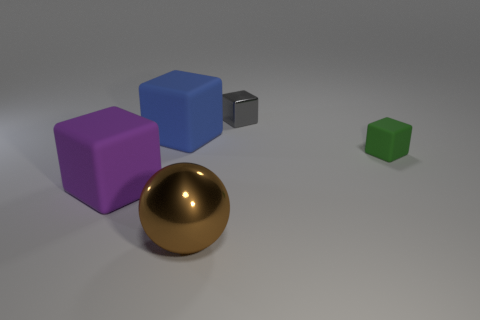The small object that is behind the rubber object that is right of the large matte object that is behind the big purple block is made of what material?
Offer a terse response. Metal. There is a big object behind the purple matte object; what is its shape?
Give a very brief answer. Cube. The thing that is the same material as the large brown sphere is what size?
Provide a succinct answer. Small. What number of blue objects are the same shape as the green matte thing?
Give a very brief answer. 1. Do the matte object in front of the small green matte block and the big metal thing have the same color?
Provide a short and direct response. No. How many green rubber objects are left of the big matte thing behind the object that is to the left of the blue matte cube?
Make the answer very short. 0. How many matte objects are right of the metal ball and left of the big brown shiny thing?
Provide a succinct answer. 0. Is there anything else that is the same material as the brown thing?
Provide a succinct answer. Yes. Is the large sphere made of the same material as the tiny gray block?
Keep it short and to the point. Yes. There is a metal object that is in front of the thing that is right of the small gray thing that is on the left side of the small green cube; what shape is it?
Offer a very short reply. Sphere. 